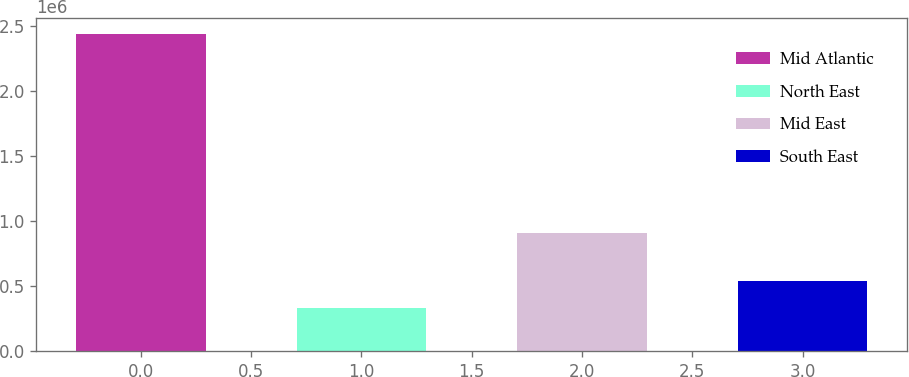<chart> <loc_0><loc_0><loc_500><loc_500><bar_chart><fcel>Mid Atlantic<fcel>North East<fcel>Mid East<fcel>South East<nl><fcel>2.43939e+06<fcel>332681<fcel>908198<fcel>543352<nl></chart> 